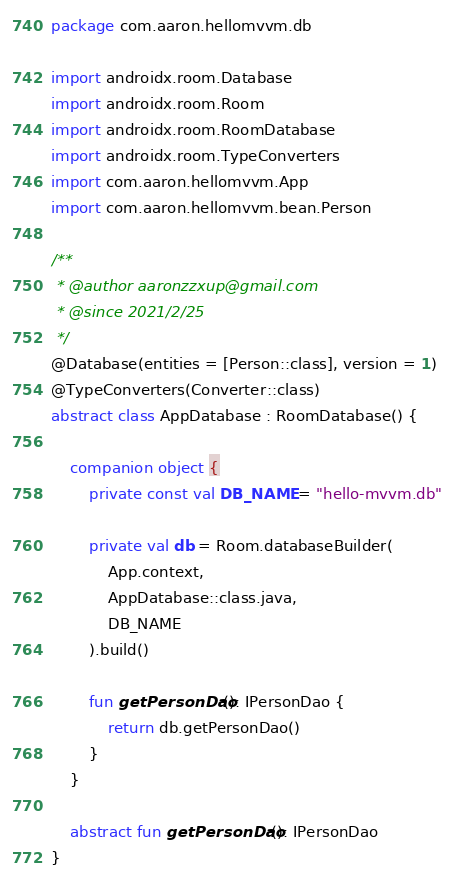<code> <loc_0><loc_0><loc_500><loc_500><_Kotlin_>package com.aaron.hellomvvm.db

import androidx.room.Database
import androidx.room.Room
import androidx.room.RoomDatabase
import androidx.room.TypeConverters
import com.aaron.hellomvvm.App
import com.aaron.hellomvvm.bean.Person

/**
 * @author aaronzzxup@gmail.com
 * @since 2021/2/25
 */
@Database(entities = [Person::class], version = 1)
@TypeConverters(Converter::class)
abstract class AppDatabase : RoomDatabase() {

    companion object {
        private const val DB_NAME = "hello-mvvm.db"

        private val db = Room.databaseBuilder(
            App.context,
            AppDatabase::class.java,
            DB_NAME
        ).build()

        fun getPersonDao(): IPersonDao {
            return db.getPersonDao()
        }
    }

    abstract fun getPersonDao(): IPersonDao
}</code> 